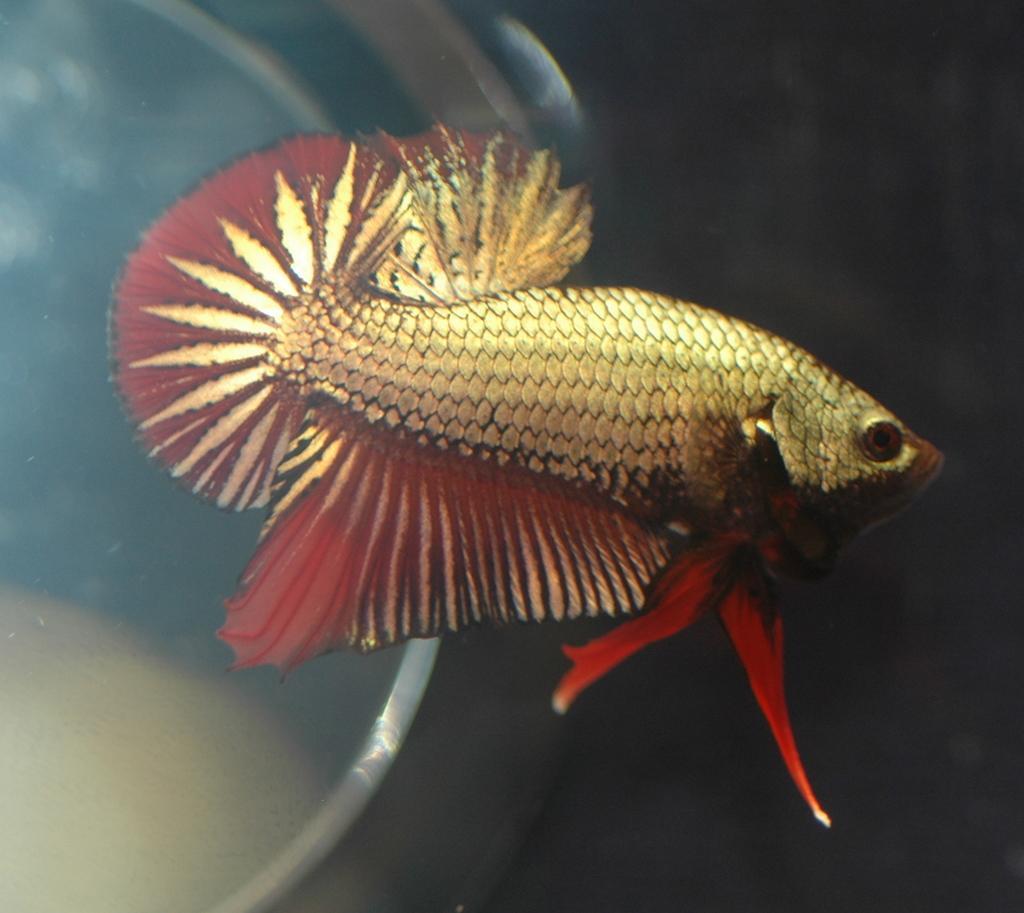How would you summarize this image in a sentence or two? In this image, I can see a fish. This looks like a glass bowl. 